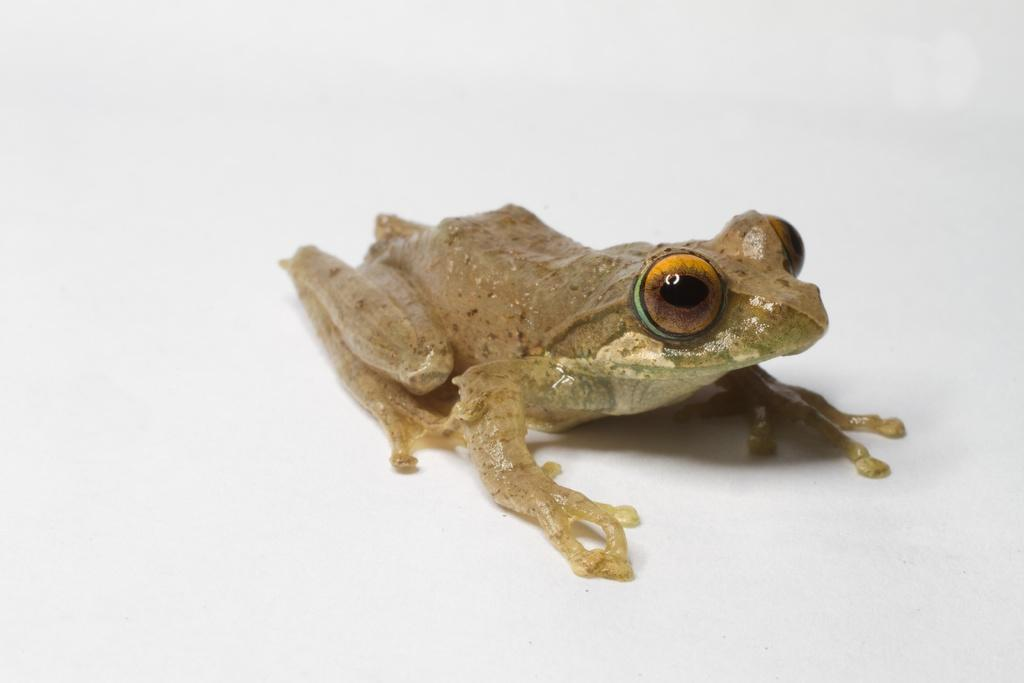What type of animal is present in the image? There is a frog in the image. How many books are visible in the image? There are no books present in the image; it features a frog. Is there a ghost visible in the image? There is no ghost present in the image; it features a frog. 